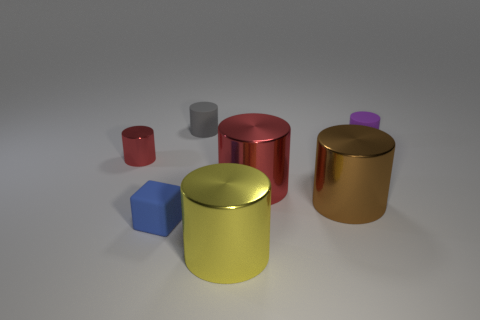There is a tiny red metal cylinder; what number of small red things are right of it?
Give a very brief answer. 0. Do the object in front of the blue block and the small block have the same material?
Keep it short and to the point. No. How many small red things are the same shape as the small purple rubber object?
Provide a short and direct response. 1. What number of small things are either brown metallic things or green shiny blocks?
Keep it short and to the point. 0. Is the color of the matte thing that is behind the tiny purple rubber object the same as the cube?
Ensure brevity in your answer.  No. Do the small matte cylinder left of the purple matte thing and the tiny thing that is in front of the tiny metal object have the same color?
Give a very brief answer. No. Is there another purple object made of the same material as the purple object?
Your response must be concise. No. What number of yellow things are small matte things or tiny objects?
Offer a very short reply. 0. Are there more big yellow objects that are behind the tiny metal object than tiny blue blocks?
Your answer should be very brief. No. Is the blue thing the same size as the yellow object?
Give a very brief answer. No. 